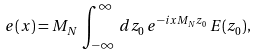<formula> <loc_0><loc_0><loc_500><loc_500>e ( x ) = M _ { N } \, \int _ { - \infty } ^ { \infty } \, d z _ { 0 } \, e ^ { - i x M _ { N } z _ { 0 } } \, E ( z _ { 0 } ) ,</formula> 